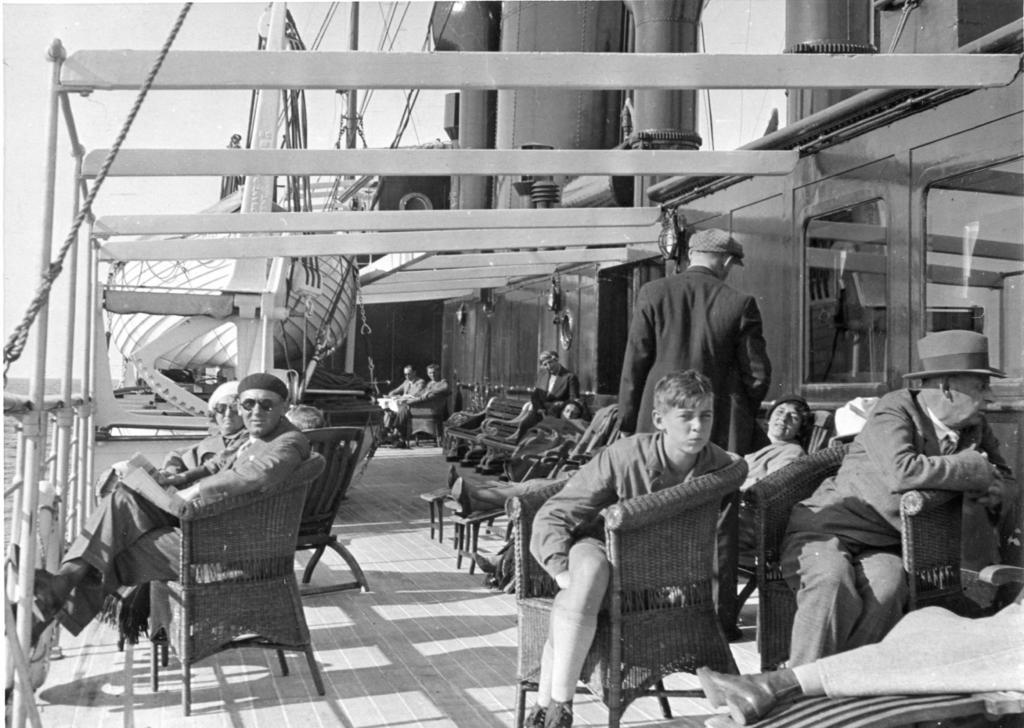How would you summarize this image in a sentence or two? This is a picture in the boat where we can see some group of people sitting on the chairs. 